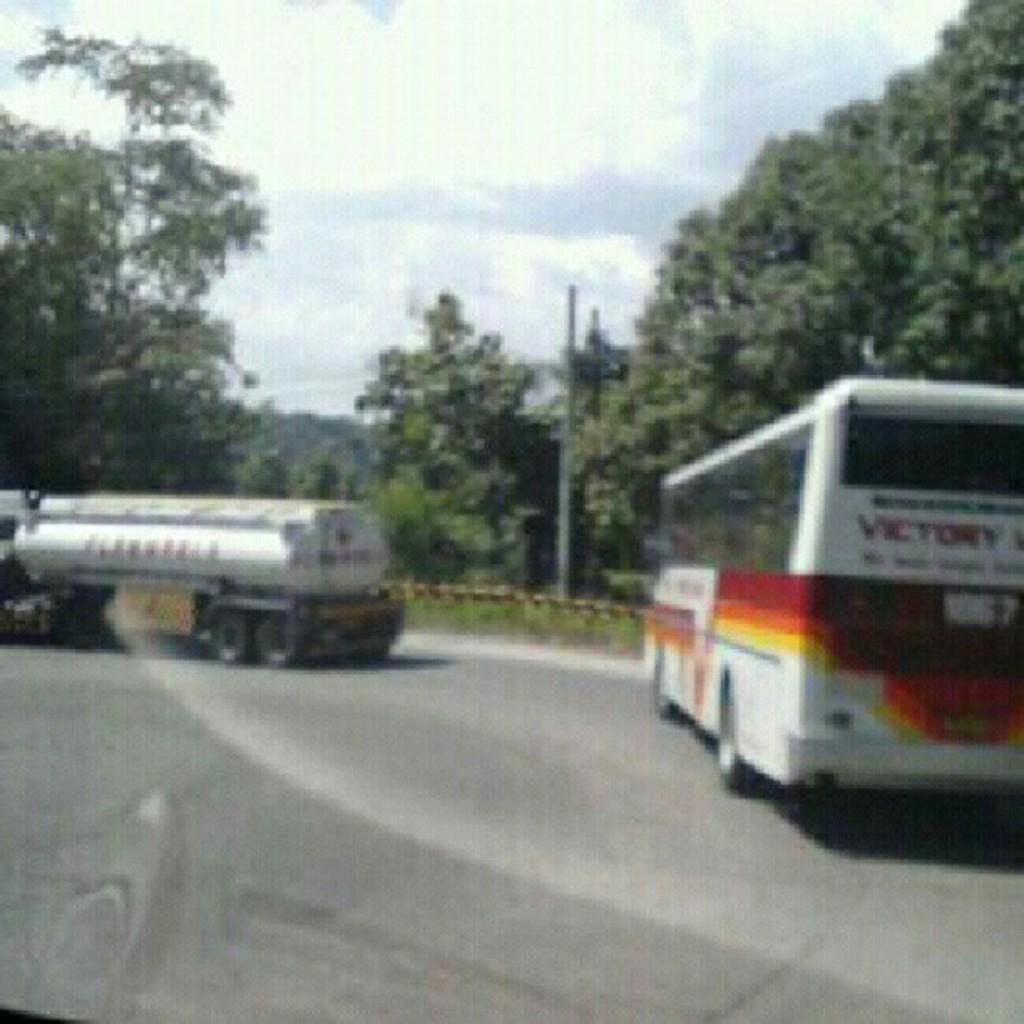What is the main subject of the image? There is a bus in the image. What else can be seen on the road in the image? There is a vehicle parked on the road. What structure is present near the road in the image? There is a street light pole in the image. What type of vegetation is visible in the image? There are trees in the image. How would you describe the weather in the image? The sky is cloudy in the image. What type of bird can be seen combing its hair in the image? There is no bird or hair present in the image. 